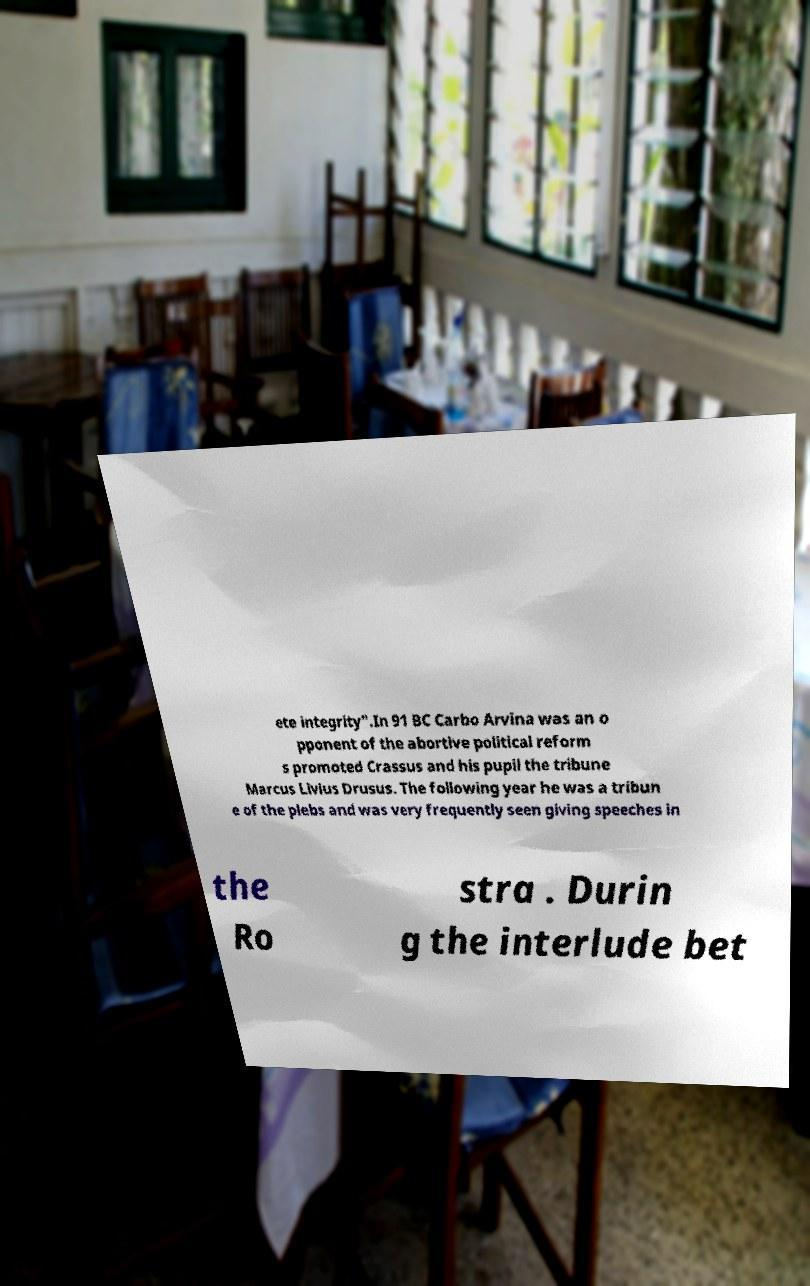Please read and relay the text visible in this image. What does it say? ete integrity".In 91 BC Carbo Arvina was an o pponent of the abortive political reform s promoted Crassus and his pupil the tribune Marcus Livius Drusus. The following year he was a tribun e of the plebs and was very frequently seen giving speeches in the Ro stra . Durin g the interlude bet 